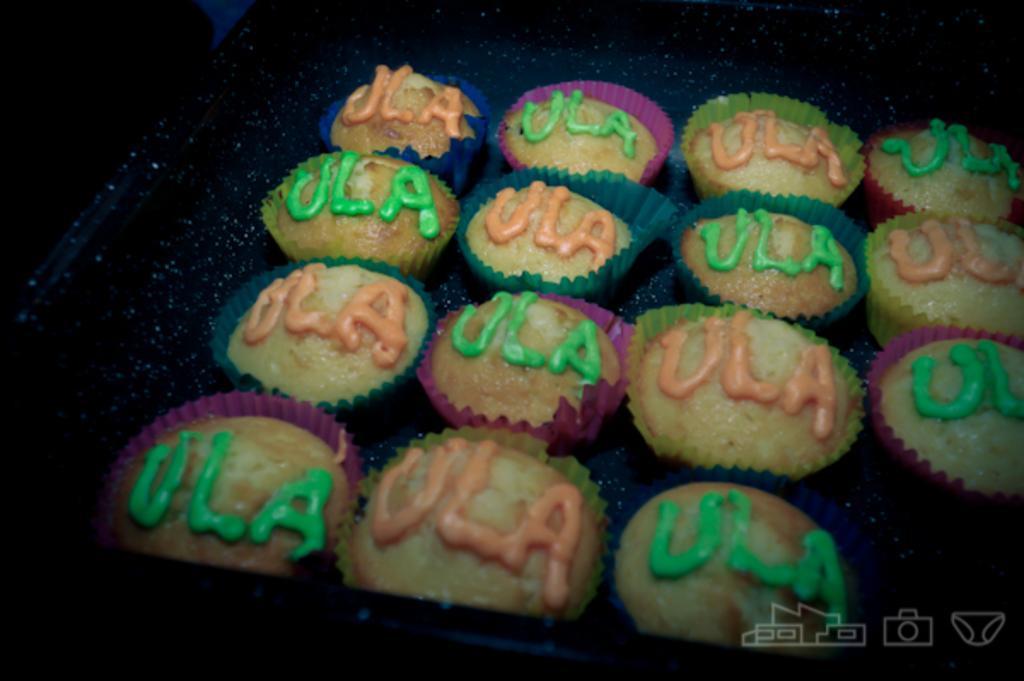In one or two sentences, can you explain what this image depicts? In this image I can see few cupcakes. The background is in black color. 